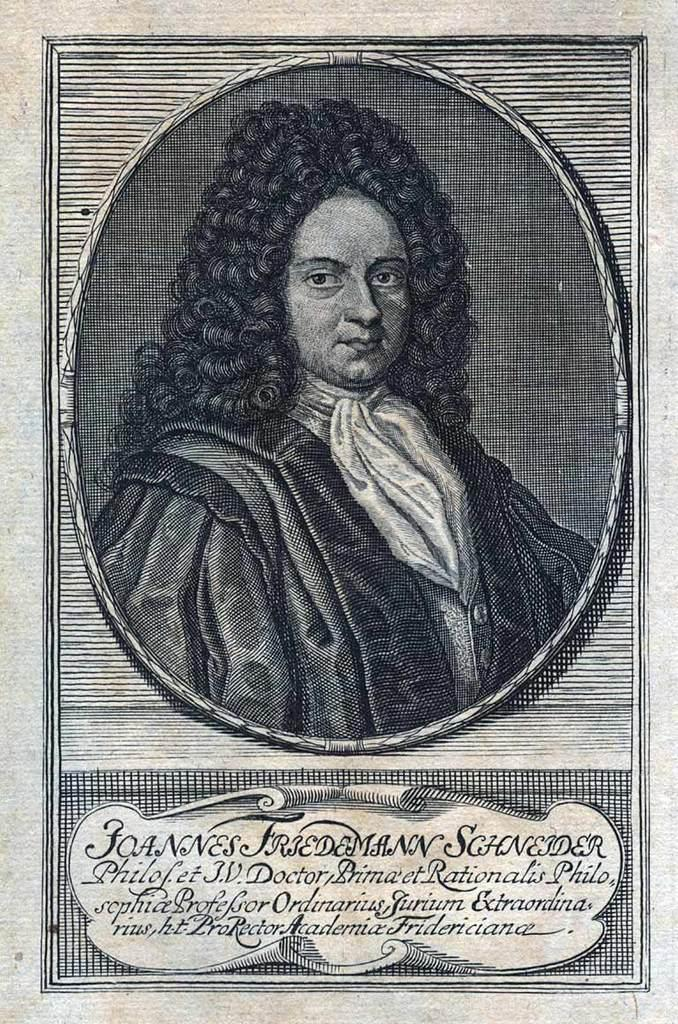Provide a one-sentence caption for the provided image. An image that looks like a lithograph of a person in a Victorian wig and clothing references Joannes Friedemann Schneider. 